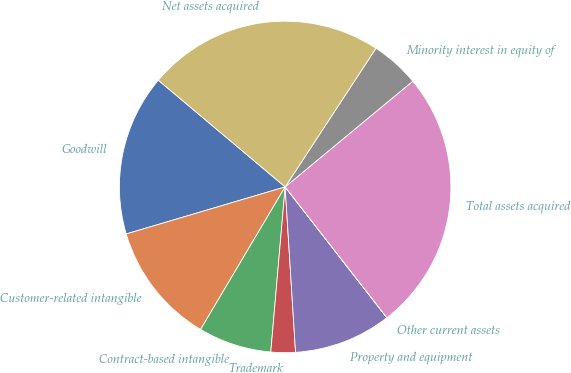Convert chart. <chart><loc_0><loc_0><loc_500><loc_500><pie_chart><fcel>Goodwill<fcel>Customer-related intangible<fcel>Contract-based intangible<fcel>Trademark<fcel>Property and equipment<fcel>Other current assets<fcel>Total assets acquired<fcel>Minority interest in equity of<fcel>Net assets acquired<nl><fcel>15.71%<fcel>11.9%<fcel>7.14%<fcel>2.38%<fcel>9.52%<fcel>0.01%<fcel>25.48%<fcel>4.76%<fcel>23.1%<nl></chart> 